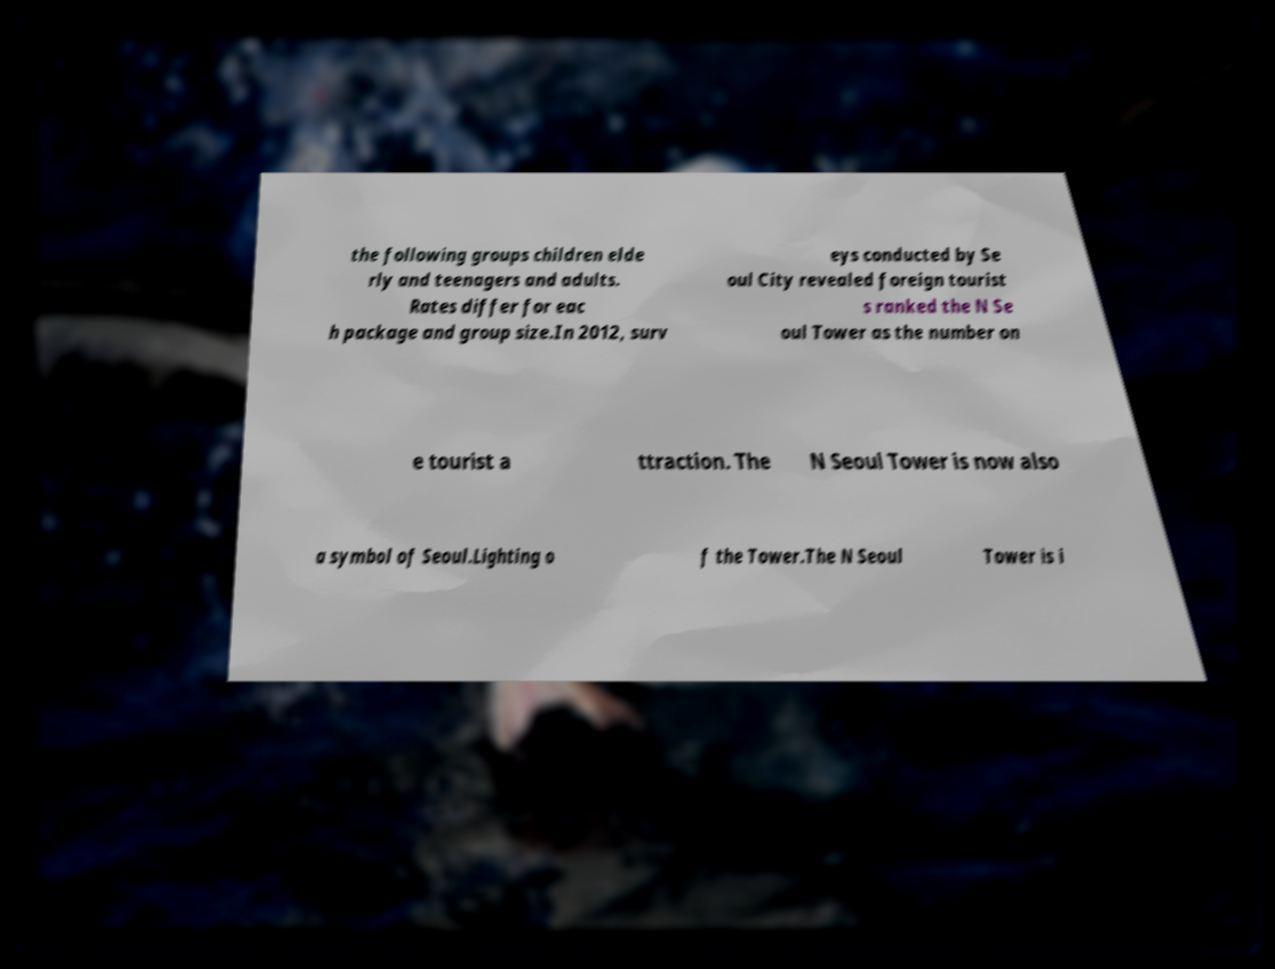There's text embedded in this image that I need extracted. Can you transcribe it verbatim? the following groups children elde rly and teenagers and adults. Rates differ for eac h package and group size.In 2012, surv eys conducted by Se oul City revealed foreign tourist s ranked the N Se oul Tower as the number on e tourist a ttraction. The N Seoul Tower is now also a symbol of Seoul.Lighting o f the Tower.The N Seoul Tower is i 